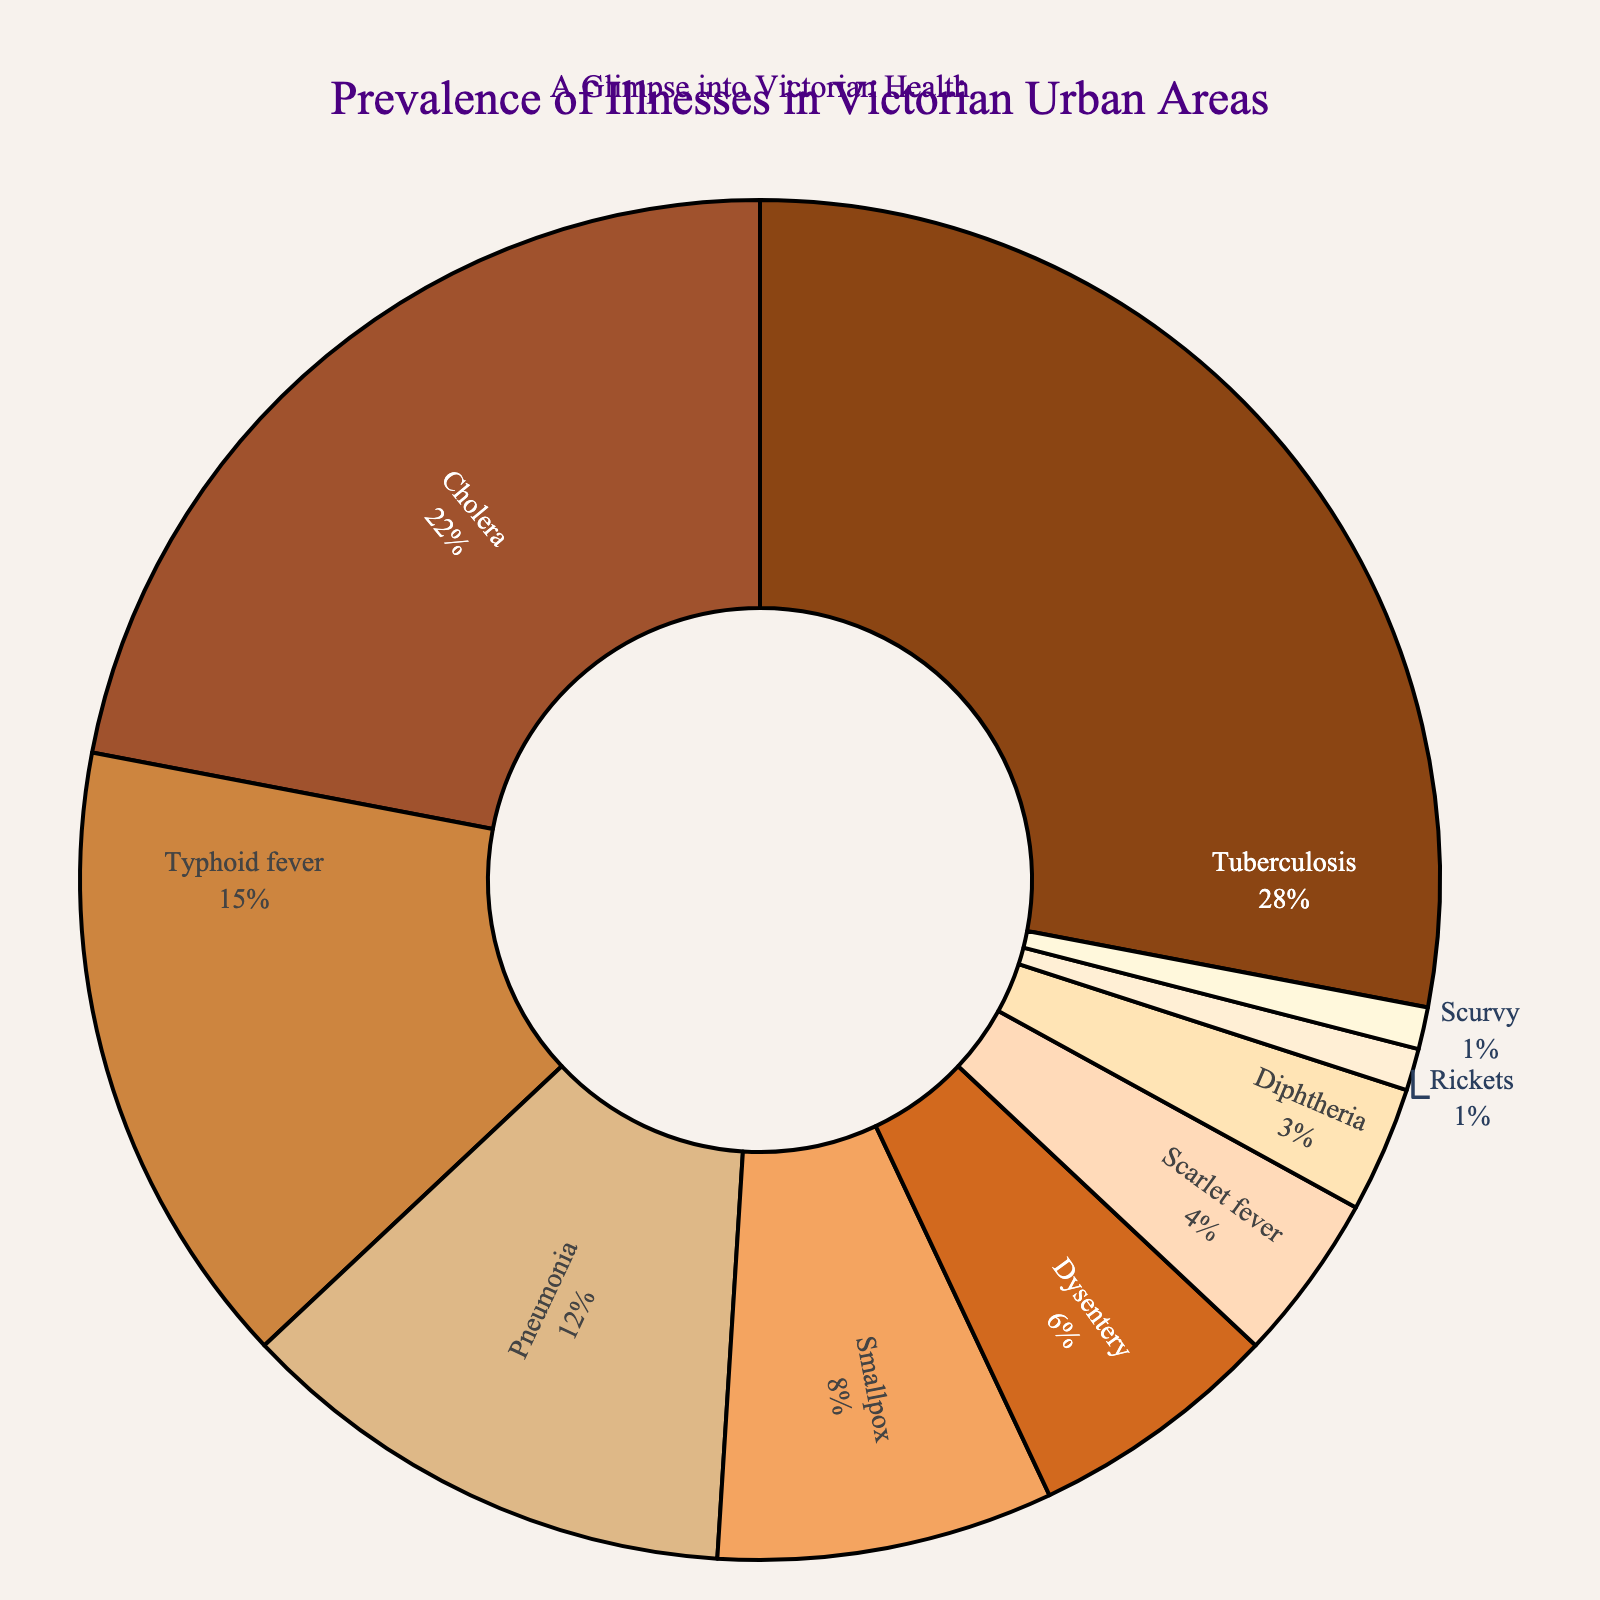What illness has the highest prevalence in Victorian urban areas? Tuberculosis has the highest prevalence. By observing the pie chart, the segment associated with Tuberculosis is the largest, indicating its highest proportion.
Answer: Tuberculosis Which two illnesses have the lowest prevalence and how do their proportions compare? Rickets and Scurvy both have the lowest prevalence, each representing 1% of the total. By comparing the segments, they are equal in size, indicating they are both the least prevalent.
Answer: Rickets and Scurvy, equal What is the combined prevalence of Cholera and Typhoid fever? Adding the prevalence percentages for Cholera (22%) and Typhoid fever (15%), we get 22 + 15 = 37.
Answer: 37% Which illness is more prevalent, Pneumonia or Smallpox, and by how much? Pneumonia (12%) is more prevalent than Smallpox (8%). The difference can be calculated as 12 - 8 = 4.
Answer: Pneumonia by 4% What is the combined prevalence of all illnesses except Tuberculosis? Subtract the prevalence of Tuberculosis (28%) from 100%: 100 - 28 = 72. Therefore, the combined prevalence of all other illnesses is 72%.
Answer: 72% Rank the illnesses from highest to lowest prevalence. Observing the pie chart, the illnesses can be ranked as follows: Tuberculosis, Cholera, Typhoid fever, Pneumonia, Smallpox, Dysentery, Scarlet fever, Diphtheria, Rickets, and Scurvy.
Answer: Tuberculosis, Cholera, Typhoid fever, Pneumonia, Smallpox, Dysentery, Scarlet fever, Diphtheria, Rickets, Scurvy Which illness occupies the medium-sized segment between Dysentery and Rickets? The segment between Dysentery (6%) and Rickets (1%) is for Scarlet fever, which has a prevalence of 4%.
Answer: Scarlet fever What is the difference in prevalence between the top three illnesses combined and the bottom three illnesses combined? Adding the top three prevalences: Tuberculosis (28%), Cholera (22%), and Typhoid fever (15%) gives 28 + 22 + 15 = 65. Adding the bottom three prevalences: Diphtheria (3%), Rickets (1%), and Scurvy (1%) gives 3 + 1 + 1 = 5. The difference is 65 - 5 = 60.
Answer: 60 What is the total prevalence of illnesses with a prevalence of less than 10%? Summing the prevalence of illnesses with less than 10%: Smallpox (8%), Dysentery (6%), Scarlet fever (4%), Diphtheria (3%), Rickets (1%), and Scurvy (1%), we get 8 + 6 + 4 + 3 + 1 + 1 = 23.
Answer: 23% 